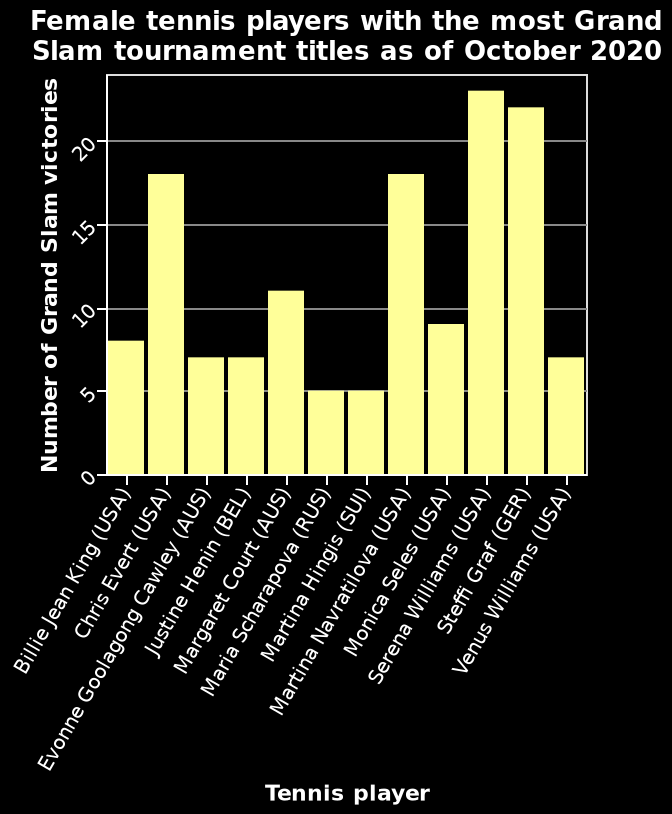<image>
What does the bar diagram represent?  The bar diagram represents the Female tennis players with the most Grand Slam tournament titles. Who are the players with the same number of grand slam wins? Navratilova and Chris Evert. Offer a thorough analysis of the image. The player with the most grand slams as of 2020 is Serena Williams, followed closely by Steffi Graf Next are Navratilova and Chris Evert who both have the same number of wins. Maria Scharapova and Martina Hingis are joint for the lowest number of gran slams. 